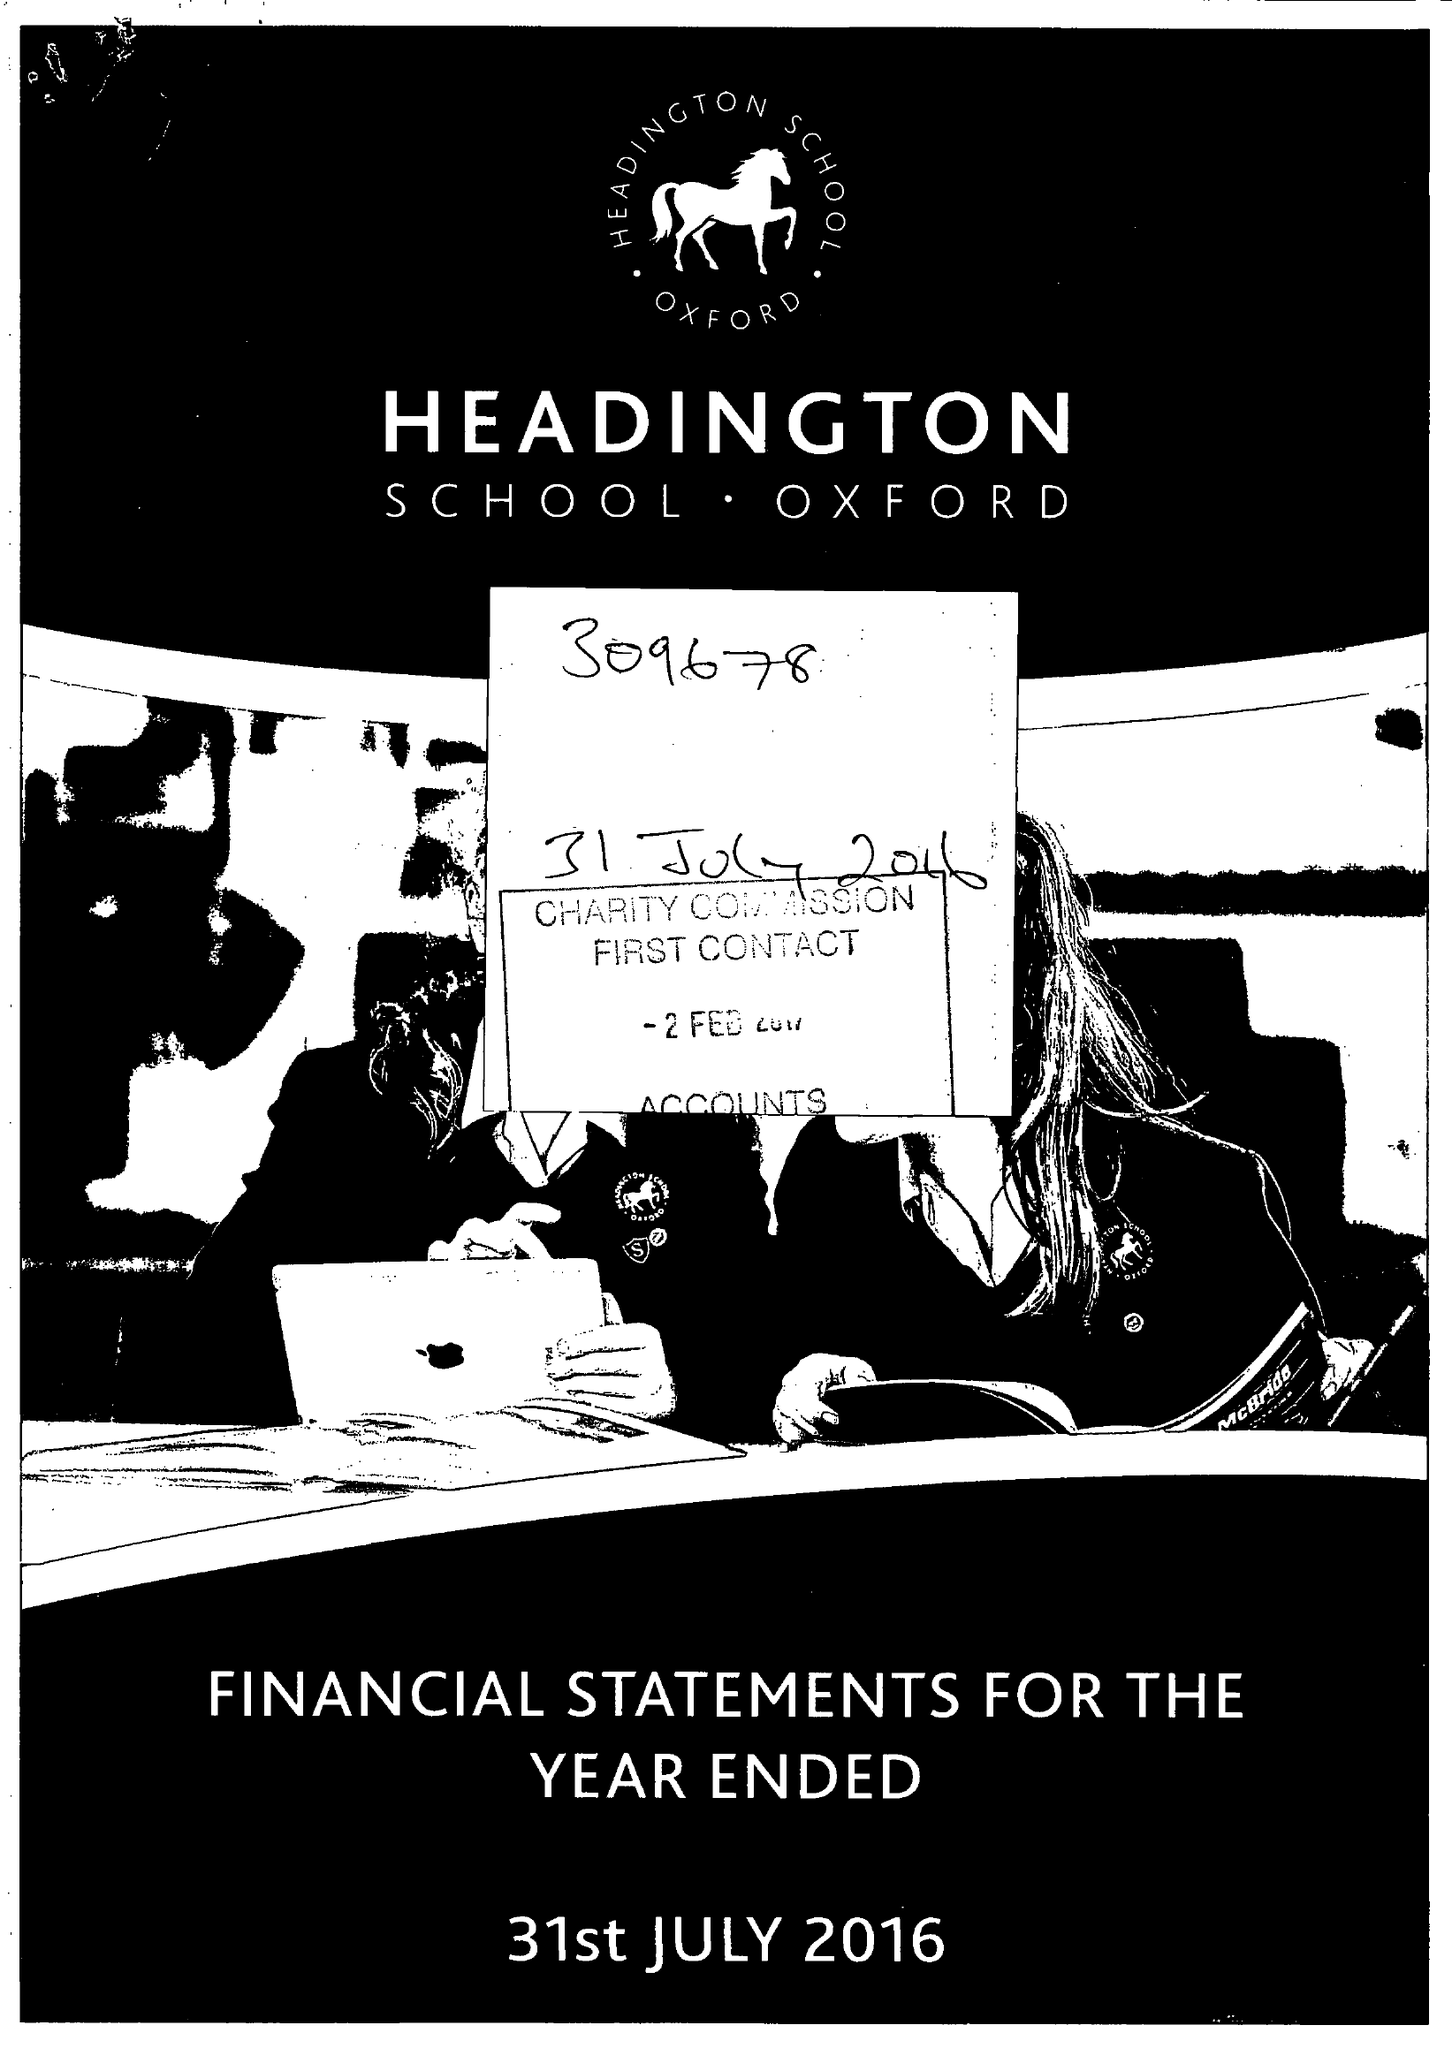What is the value for the report_date?
Answer the question using a single word or phrase. 2016-07-31 